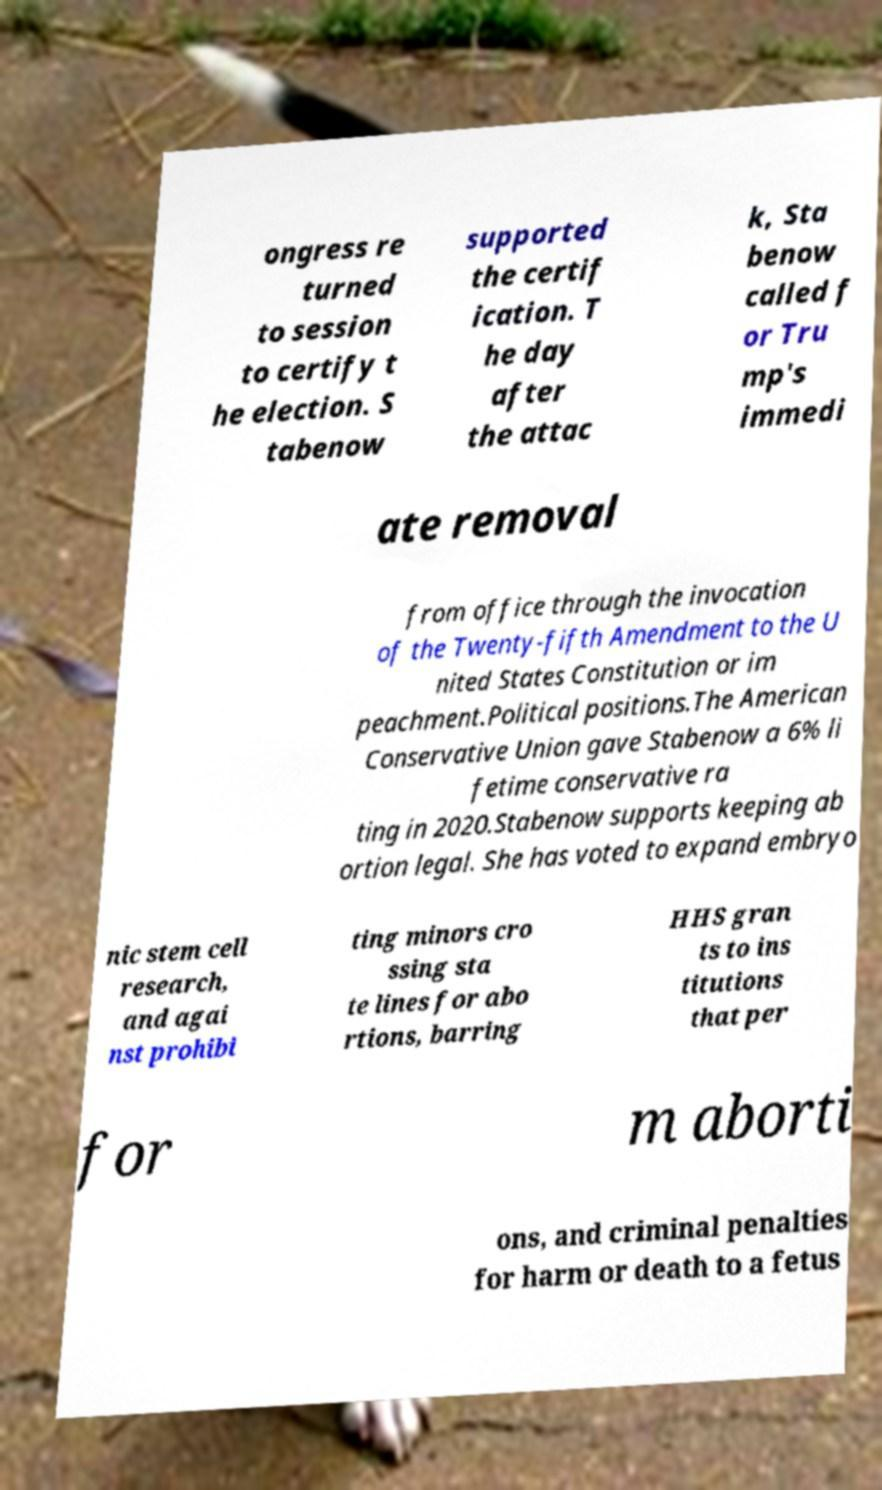For documentation purposes, I need the text within this image transcribed. Could you provide that? ongress re turned to session to certify t he election. S tabenow supported the certif ication. T he day after the attac k, Sta benow called f or Tru mp's immedi ate removal from office through the invocation of the Twenty-fifth Amendment to the U nited States Constitution or im peachment.Political positions.The American Conservative Union gave Stabenow a 6% li fetime conservative ra ting in 2020.Stabenow supports keeping ab ortion legal. She has voted to expand embryo nic stem cell research, and agai nst prohibi ting minors cro ssing sta te lines for abo rtions, barring HHS gran ts to ins titutions that per for m aborti ons, and criminal penalties for harm or death to a fetus 